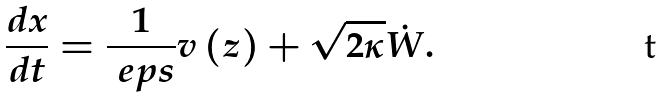<formula> <loc_0><loc_0><loc_500><loc_500>\frac { d x } { d t } = \frac { 1 } { \ e p s } v \left ( z \right ) + \sqrt { 2 \kappa } \dot { W } .</formula> 